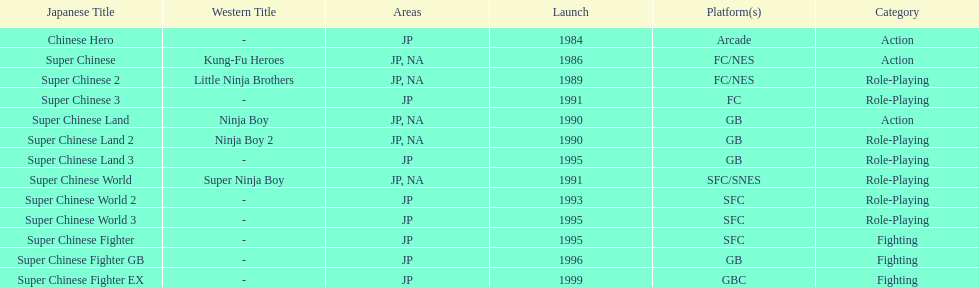How many action games were released in north america? 2. 